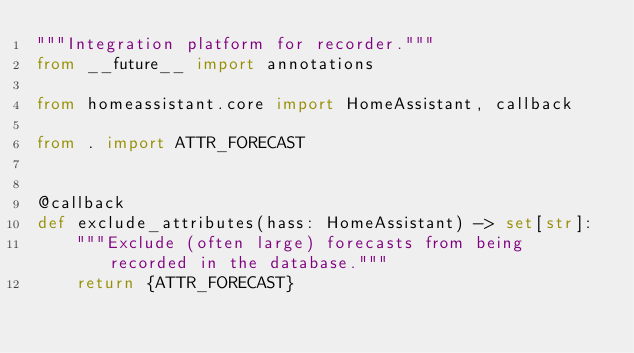<code> <loc_0><loc_0><loc_500><loc_500><_Python_>"""Integration platform for recorder."""
from __future__ import annotations

from homeassistant.core import HomeAssistant, callback

from . import ATTR_FORECAST


@callback
def exclude_attributes(hass: HomeAssistant) -> set[str]:
    """Exclude (often large) forecasts from being recorded in the database."""
    return {ATTR_FORECAST}
</code> 